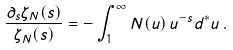Convert formula to latex. <formula><loc_0><loc_0><loc_500><loc_500>\frac { \partial _ { s } \zeta _ { N } ( s ) } { \zeta _ { N } ( s ) } = - \int _ { 1 } ^ { \infty } N ( u ) \, u ^ { - s } d ^ { * } u \, .</formula> 